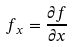Convert formula to latex. <formula><loc_0><loc_0><loc_500><loc_500>f _ { x } = \frac { \partial f } { \partial x }</formula> 